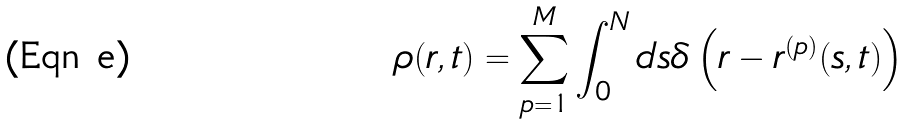Convert formula to latex. <formula><loc_0><loc_0><loc_500><loc_500>\rho ( { r } , t ) = \sum _ { p = 1 } ^ { M } \int _ { 0 } ^ { N } d s \delta \left ( { r } - { r } ^ { ( p ) } ( s , t ) \right )</formula> 